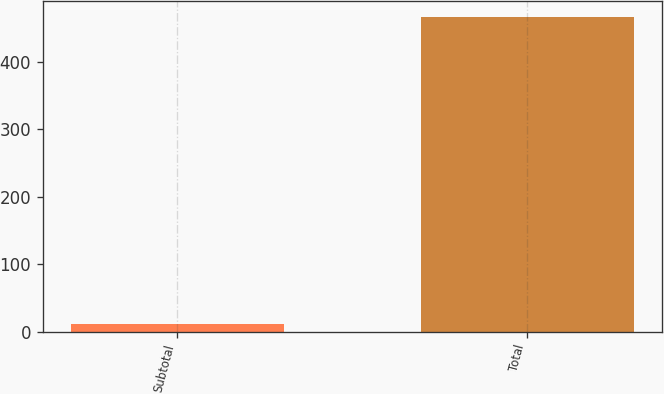Convert chart to OTSL. <chart><loc_0><loc_0><loc_500><loc_500><bar_chart><fcel>Subtotal<fcel>Total<nl><fcel>11<fcel>465.8<nl></chart> 